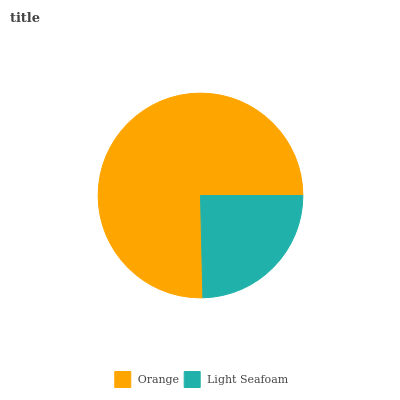Is Light Seafoam the minimum?
Answer yes or no. Yes. Is Orange the maximum?
Answer yes or no. Yes. Is Light Seafoam the maximum?
Answer yes or no. No. Is Orange greater than Light Seafoam?
Answer yes or no. Yes. Is Light Seafoam less than Orange?
Answer yes or no. Yes. Is Light Seafoam greater than Orange?
Answer yes or no. No. Is Orange less than Light Seafoam?
Answer yes or no. No. Is Orange the high median?
Answer yes or no. Yes. Is Light Seafoam the low median?
Answer yes or no. Yes. Is Light Seafoam the high median?
Answer yes or no. No. Is Orange the low median?
Answer yes or no. No. 